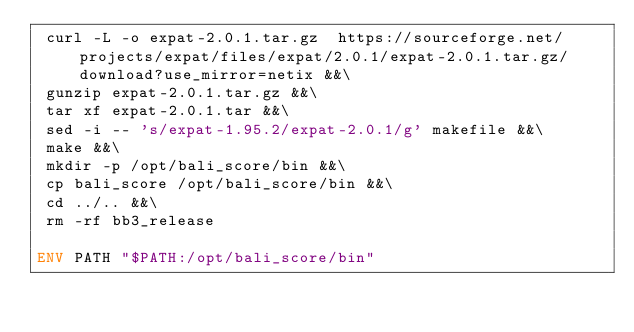<code> <loc_0><loc_0><loc_500><loc_500><_Dockerfile_> curl -L -o expat-2.0.1.tar.gz  https://sourceforge.net/projects/expat/files/expat/2.0.1/expat-2.0.1.tar.gz/download?use_mirror=netix &&\
 gunzip expat-2.0.1.tar.gz &&\
 tar xf expat-2.0.1.tar &&\
 sed -i -- 's/expat-1.95.2/expat-2.0.1/g' makefile &&\
 make &&\
 mkdir -p /opt/bali_score/bin &&\
 cp bali_score /opt/bali_score/bin &&\
 cd ../.. &&\
 rm -rf bb3_release

ENV PATH "$PATH:/opt/bali_score/bin"
</code> 